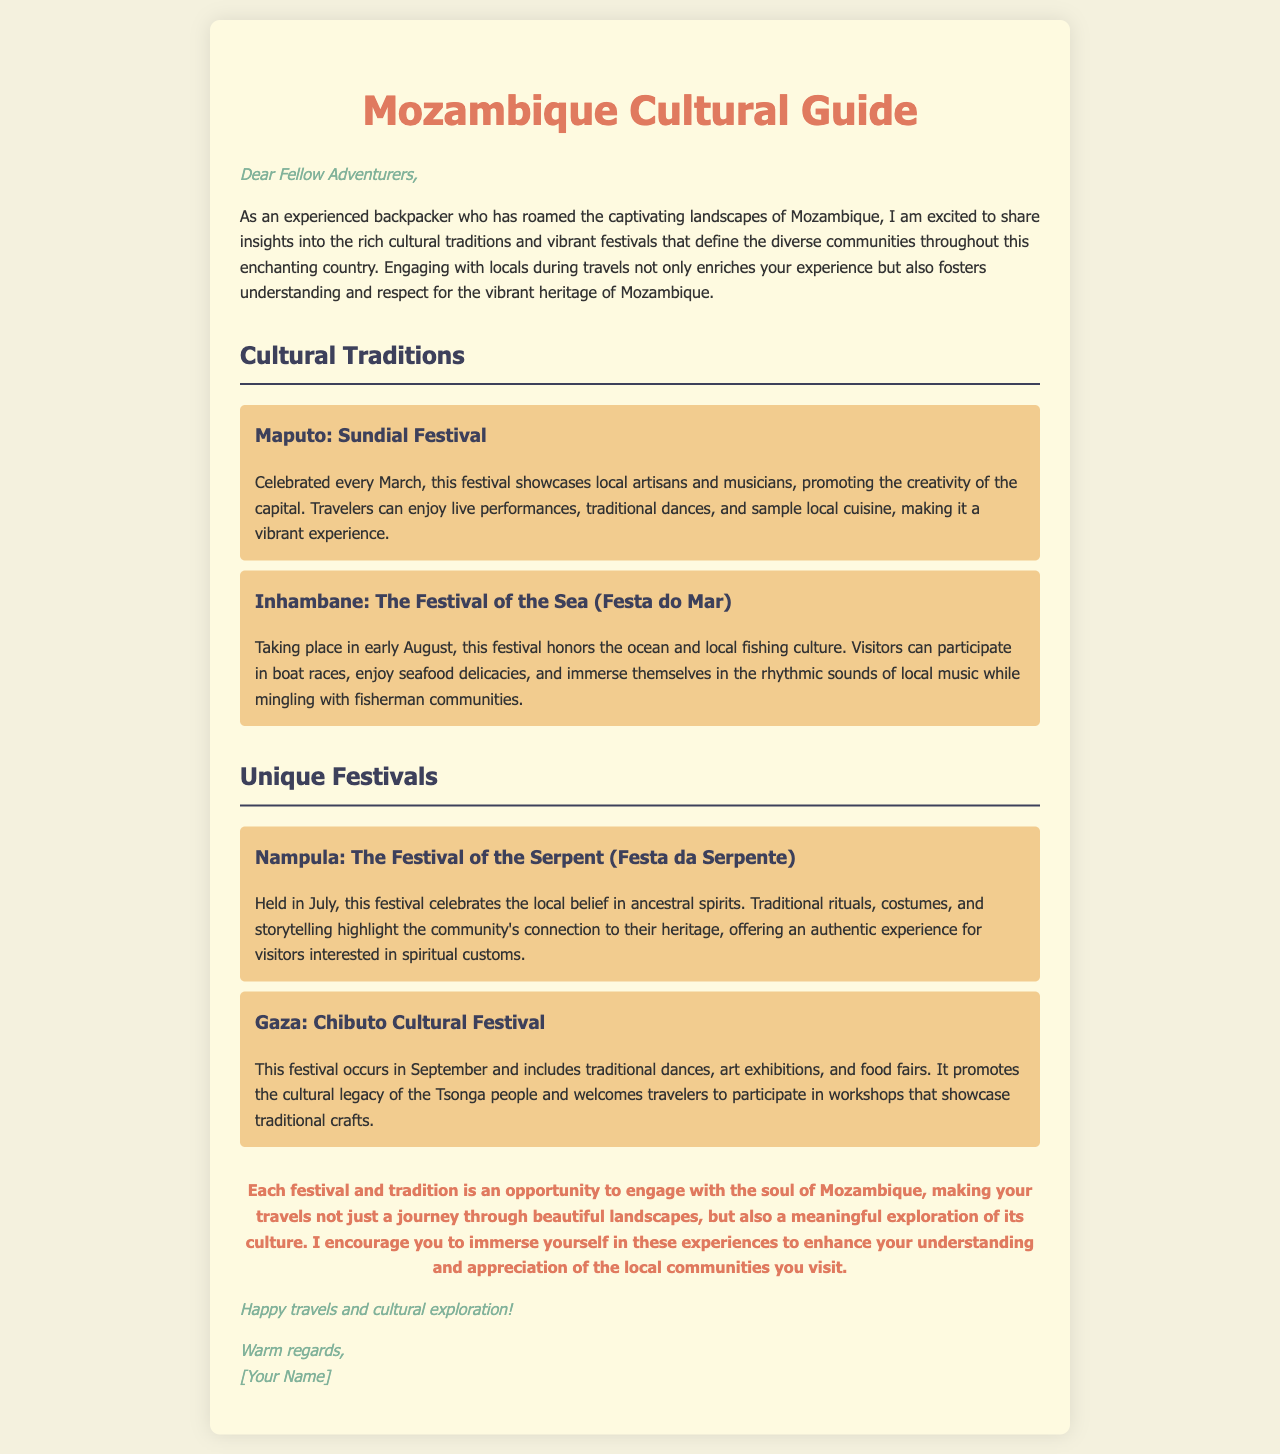What is celebrated in March in Maputo? The document states that the Sundial Festival is celebrated in March in Maputo, showcasing local artisans and musicians.
Answer: Sundial Festival When does the Festival of the Sea take place? According to the document, the Festival of the Sea is held in early August in Inhambane.
Answer: Early August What is the main theme of the Nampula festival? The document describes that the Festival of the Serpent in Nampula celebrates local belief in ancestral spirits.
Answer: Ancestral spirits In which month is the Chibuto Cultural Festival held? The document mentions that the Chibuto Cultural Festival occurs in September.
Answer: September What type of activities can travelers participate in at the Gaza festival? The document explains that the Gaza festival includes workshops showcasing traditional crafts, among other activities.
Answer: Workshops What do the festivals in Mozambique enhance for travelers? The letter emphasizes that engaging with the festivals and traditions enhances the understanding and appreciation of local communities.
Answer: Understanding and appreciation Who is the target audience of the letter? The opening greeting indicates that the letter is directed towards fellow adventurers.
Answer: Fellow Adventurers What color is mentioned for the title of the cultural guide? The document describes the color of the title as a shade of coral, specifically "#e07a5f".
Answer: Coral What is a common element shared by the festivals listed in the guide? The document notes that all the festivals involve local communities and cultural practices, enhancing traveler engagement.
Answer: Local communities and cultural practices 